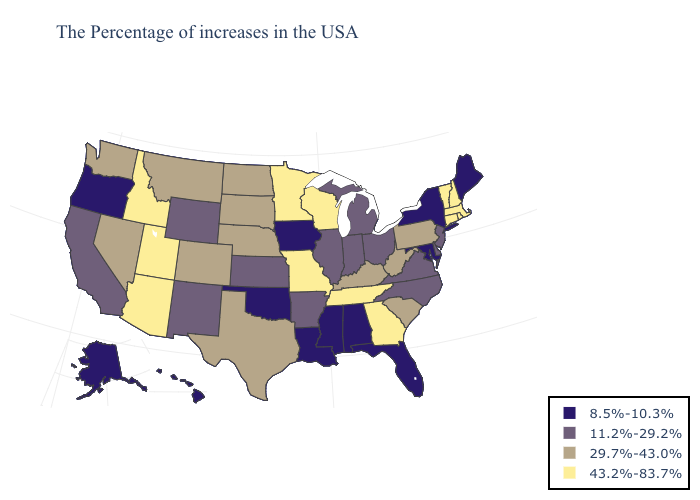What is the highest value in the West ?
Quick response, please. 43.2%-83.7%. What is the value of New Jersey?
Write a very short answer. 11.2%-29.2%. Among the states that border North Dakota , does South Dakota have the highest value?
Concise answer only. No. What is the lowest value in the MidWest?
Give a very brief answer. 8.5%-10.3%. Among the states that border Pennsylvania , does Ohio have the lowest value?
Short answer required. No. What is the highest value in the USA?
Concise answer only. 43.2%-83.7%. What is the value of Colorado?
Write a very short answer. 29.7%-43.0%. What is the lowest value in the USA?
Be succinct. 8.5%-10.3%. What is the value of Arizona?
Be succinct. 43.2%-83.7%. What is the value of Minnesota?
Quick response, please. 43.2%-83.7%. Among the states that border Connecticut , does New York have the highest value?
Be succinct. No. Which states hav the highest value in the South?
Be succinct. Georgia, Tennessee. What is the value of Washington?
Be succinct. 29.7%-43.0%. Name the states that have a value in the range 29.7%-43.0%?
Concise answer only. Pennsylvania, South Carolina, West Virginia, Kentucky, Nebraska, Texas, South Dakota, North Dakota, Colorado, Montana, Nevada, Washington. What is the highest value in the South ?
Write a very short answer. 43.2%-83.7%. 